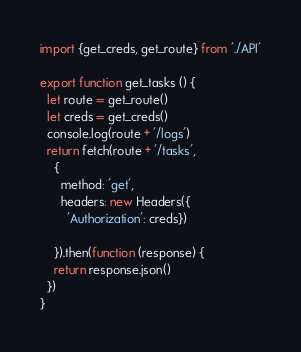<code> <loc_0><loc_0><loc_500><loc_500><_JavaScript_>import {get_creds, get_route} from './API'

export function get_tasks () {
  let route = get_route()
  let creds = get_creds()
  console.log(route + '/logs')
  return fetch(route + '/tasks',
    {
      method: 'get',
      headers: new Headers({
        'Authorization': creds})

    }).then(function (response) {
    return response.json()
  })
}
</code> 